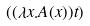Convert formula to latex. <formula><loc_0><loc_0><loc_500><loc_500>( ( \lambda x . A ( x ) ) t )</formula> 